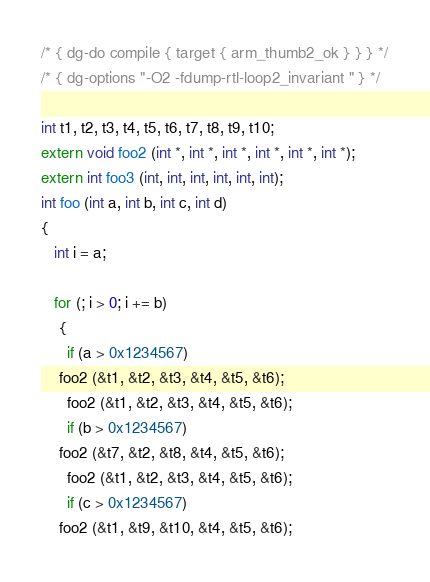<code> <loc_0><loc_0><loc_500><loc_500><_C_>/* { dg-do compile { target { arm_thumb2_ok } } } */
/* { dg-options "-O2 -fdump-rtl-loop2_invariant " } */

int t1, t2, t3, t4, t5, t6, t7, t8, t9, t10;
extern void foo2 (int *, int *, int *, int *, int *, int *);
extern int foo3 (int, int, int, int, int, int);
int foo (int a, int b, int c, int d)
{
   int i = a;

   for (; i > 0; i += b)
    {
      if (a > 0x1234567)
	foo2 (&t1, &t2, &t3, &t4, &t5, &t6);
      foo2 (&t1, &t2, &t3, &t4, &t5, &t6);
      if (b > 0x1234567)
	foo2 (&t7, &t2, &t8, &t4, &t5, &t6);
      foo2 (&t1, &t2, &t3, &t4, &t5, &t6);
      if (c > 0x1234567)
	foo2 (&t1, &t9, &t10, &t4, &t5, &t6);</code> 